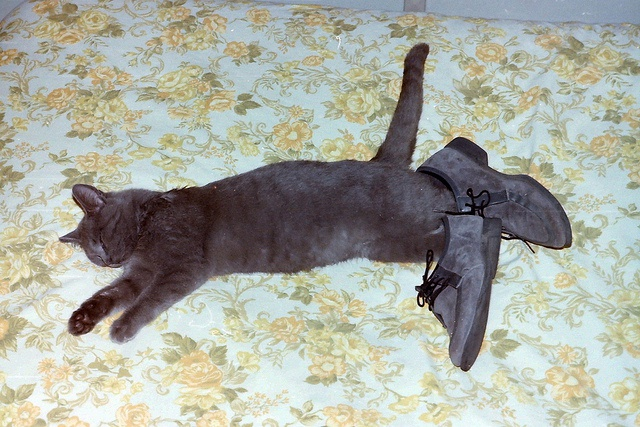Describe the objects in this image and their specific colors. I can see bed in lightgray, darkgray, beige, gray, and lightblue tones and cat in gray and black tones in this image. 